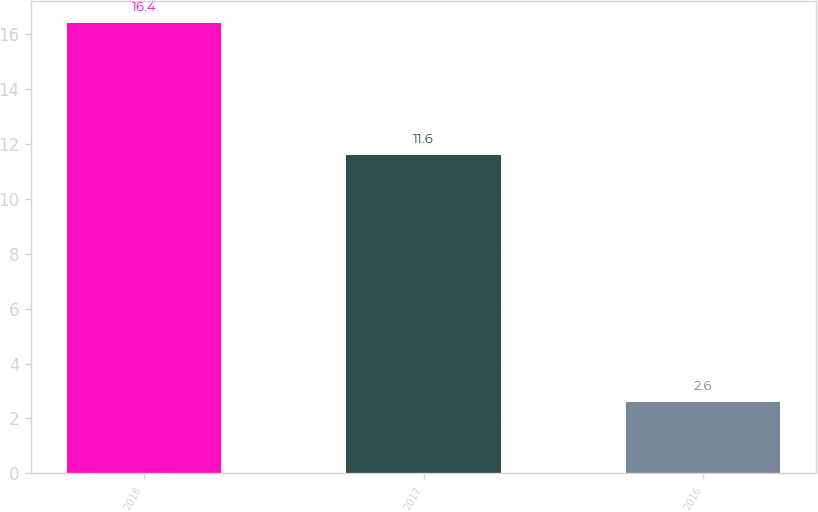Convert chart to OTSL. <chart><loc_0><loc_0><loc_500><loc_500><bar_chart><fcel>2018<fcel>2017<fcel>2016<nl><fcel>16.4<fcel>11.6<fcel>2.6<nl></chart> 